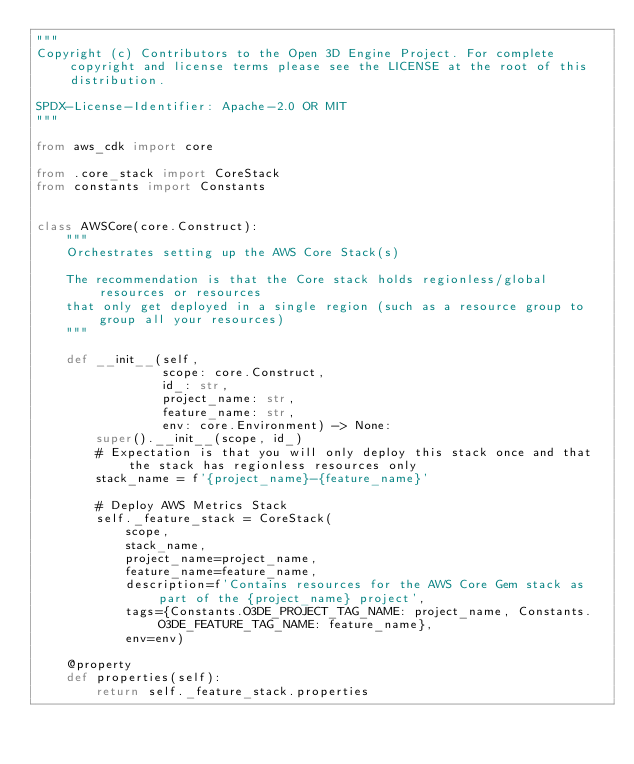<code> <loc_0><loc_0><loc_500><loc_500><_Python_>"""
Copyright (c) Contributors to the Open 3D Engine Project. For complete copyright and license terms please see the LICENSE at the root of this distribution.

SPDX-License-Identifier: Apache-2.0 OR MIT
"""

from aws_cdk import core

from .core_stack import CoreStack
from constants import Constants


class AWSCore(core.Construct):
    """
    Orchestrates setting up the AWS Core Stack(s)

    The recommendation is that the Core stack holds regionless/global resources or resources
    that only get deployed in a single region (such as a resource group to group all your resources)
    """

    def __init__(self,
                 scope: core.Construct,
                 id_: str,
                 project_name: str,
                 feature_name: str,
                 env: core.Environment) -> None:
        super().__init__(scope, id_)
        # Expectation is that you will only deploy this stack once and that the stack has regionless resources only
        stack_name = f'{project_name}-{feature_name}'

        # Deploy AWS Metrics Stack
        self._feature_stack = CoreStack(
            scope,
            stack_name,
            project_name=project_name,
            feature_name=feature_name,
            description=f'Contains resources for the AWS Core Gem stack as part of the {project_name} project',
            tags={Constants.O3DE_PROJECT_TAG_NAME: project_name, Constants.O3DE_FEATURE_TAG_NAME: feature_name},
            env=env)

    @property
    def properties(self):
        return self._feature_stack.properties
</code> 